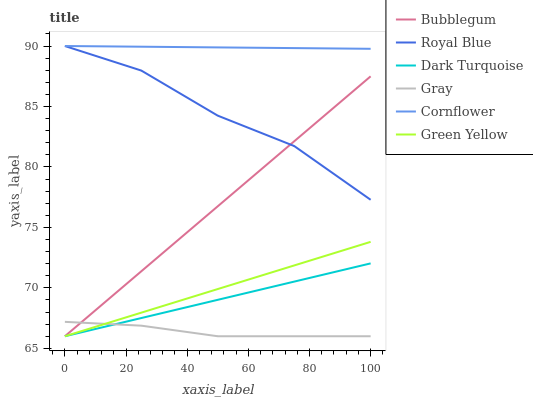Does Gray have the minimum area under the curve?
Answer yes or no. Yes. Does Cornflower have the maximum area under the curve?
Answer yes or no. Yes. Does Dark Turquoise have the minimum area under the curve?
Answer yes or no. No. Does Dark Turquoise have the maximum area under the curve?
Answer yes or no. No. Is Cornflower the smoothest?
Answer yes or no. Yes. Is Royal Blue the roughest?
Answer yes or no. Yes. Is Dark Turquoise the smoothest?
Answer yes or no. No. Is Dark Turquoise the roughest?
Answer yes or no. No. Does Gray have the lowest value?
Answer yes or no. Yes. Does Cornflower have the lowest value?
Answer yes or no. No. Does Royal Blue have the highest value?
Answer yes or no. Yes. Does Dark Turquoise have the highest value?
Answer yes or no. No. Is Bubblegum less than Cornflower?
Answer yes or no. Yes. Is Cornflower greater than Bubblegum?
Answer yes or no. Yes. Does Bubblegum intersect Green Yellow?
Answer yes or no. Yes. Is Bubblegum less than Green Yellow?
Answer yes or no. No. Is Bubblegum greater than Green Yellow?
Answer yes or no. No. Does Bubblegum intersect Cornflower?
Answer yes or no. No. 